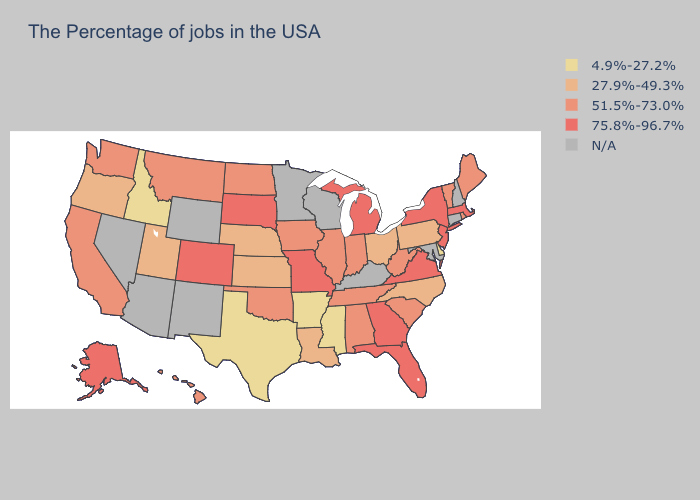Name the states that have a value in the range 75.8%-96.7%?
Quick response, please. Massachusetts, New York, New Jersey, Virginia, Florida, Georgia, Michigan, Missouri, South Dakota, Colorado, Alaska. Does Washington have the highest value in the West?
Quick response, please. No. What is the highest value in states that border North Carolina?
Concise answer only. 75.8%-96.7%. What is the value of Alabama?
Answer briefly. 51.5%-73.0%. What is the lowest value in the USA?
Short answer required. 4.9%-27.2%. How many symbols are there in the legend?
Short answer required. 5. Does South Dakota have the lowest value in the USA?
Give a very brief answer. No. Is the legend a continuous bar?
Keep it brief. No. What is the value of Montana?
Quick response, please. 51.5%-73.0%. Name the states that have a value in the range N/A?
Give a very brief answer. New Hampshire, Connecticut, Maryland, Kentucky, Wisconsin, Minnesota, Wyoming, New Mexico, Arizona, Nevada. What is the value of Colorado?
Answer briefly. 75.8%-96.7%. Name the states that have a value in the range 75.8%-96.7%?
Keep it brief. Massachusetts, New York, New Jersey, Virginia, Florida, Georgia, Michigan, Missouri, South Dakota, Colorado, Alaska. What is the highest value in the South ?
Quick response, please. 75.8%-96.7%. Among the states that border Minnesota , does South Dakota have the highest value?
Quick response, please. Yes. Name the states that have a value in the range 4.9%-27.2%?
Write a very short answer. Delaware, Mississippi, Arkansas, Texas, Idaho. 